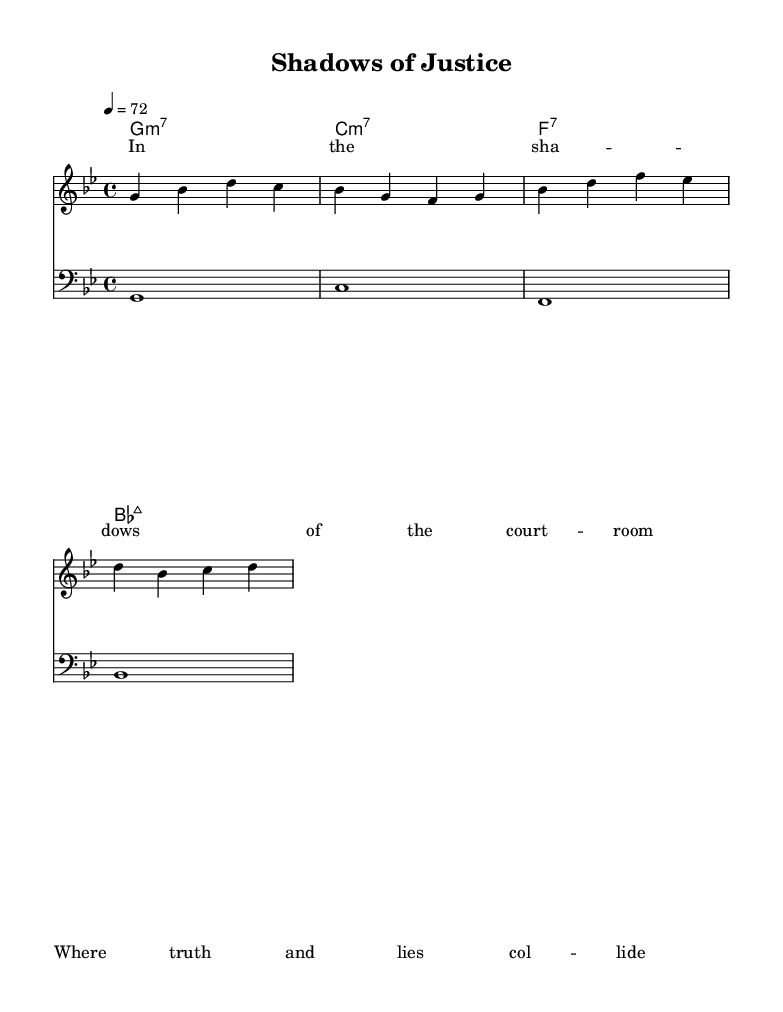What is the key signature of this music? The key signature is G minor, which contains two flats (B♭ and E♭). This can be determined by looking at the key signature section in the beginning of the sheet music.
Answer: G minor What is the time signature of this piece? The time signature is 4/4, which is indicated at the start of the music sheet. This means there are four beats in each measure and the quarter note gets one beat.
Answer: 4/4 What is the tempo marking for this piece? The tempo marking is 72 beats per minute, indicated at the beginning of the music. This setting determines how fast the piece should be played.
Answer: 72 Which chord is written in the second measure of the harmonies? The chord in the second measure is C minor 7, identified by the notation in the chord section which directly corresponds to the harmonic accompaniment of the piece.
Answer: C minor 7 What emotions do the lyrics likely convey in this soul tune? The lyrics suggest themes of conflict between truth and deception, as highlighted by phrases like "shadows of the courtroom" and "where truth and lies collide." The choice of words indicates a reflective and possibly somber mood.
Answer: Conflict Explain the relationship between the melody and the bass line. The melody in the treble staff often interacts harmonically with the bass line in the bass staff, providing a fuller sound that aligns with the chords below. The bass line outlines the fundamental notes of each chord, while the melody explores variations and adds emotional depth. Both elements work together to create a cohesive musical experience.
Answer: Harmony Why is this piece categorized as Soul music? This piece can be categorized as Soul music due to its expressive melody, lyrical content that reflects deep emotional themes, and the use of jazz-influenced harmonies typical of the genre. The combination of these elements often evokes a strong emotional response, characteristic of soul music.
Answer: Expressive 